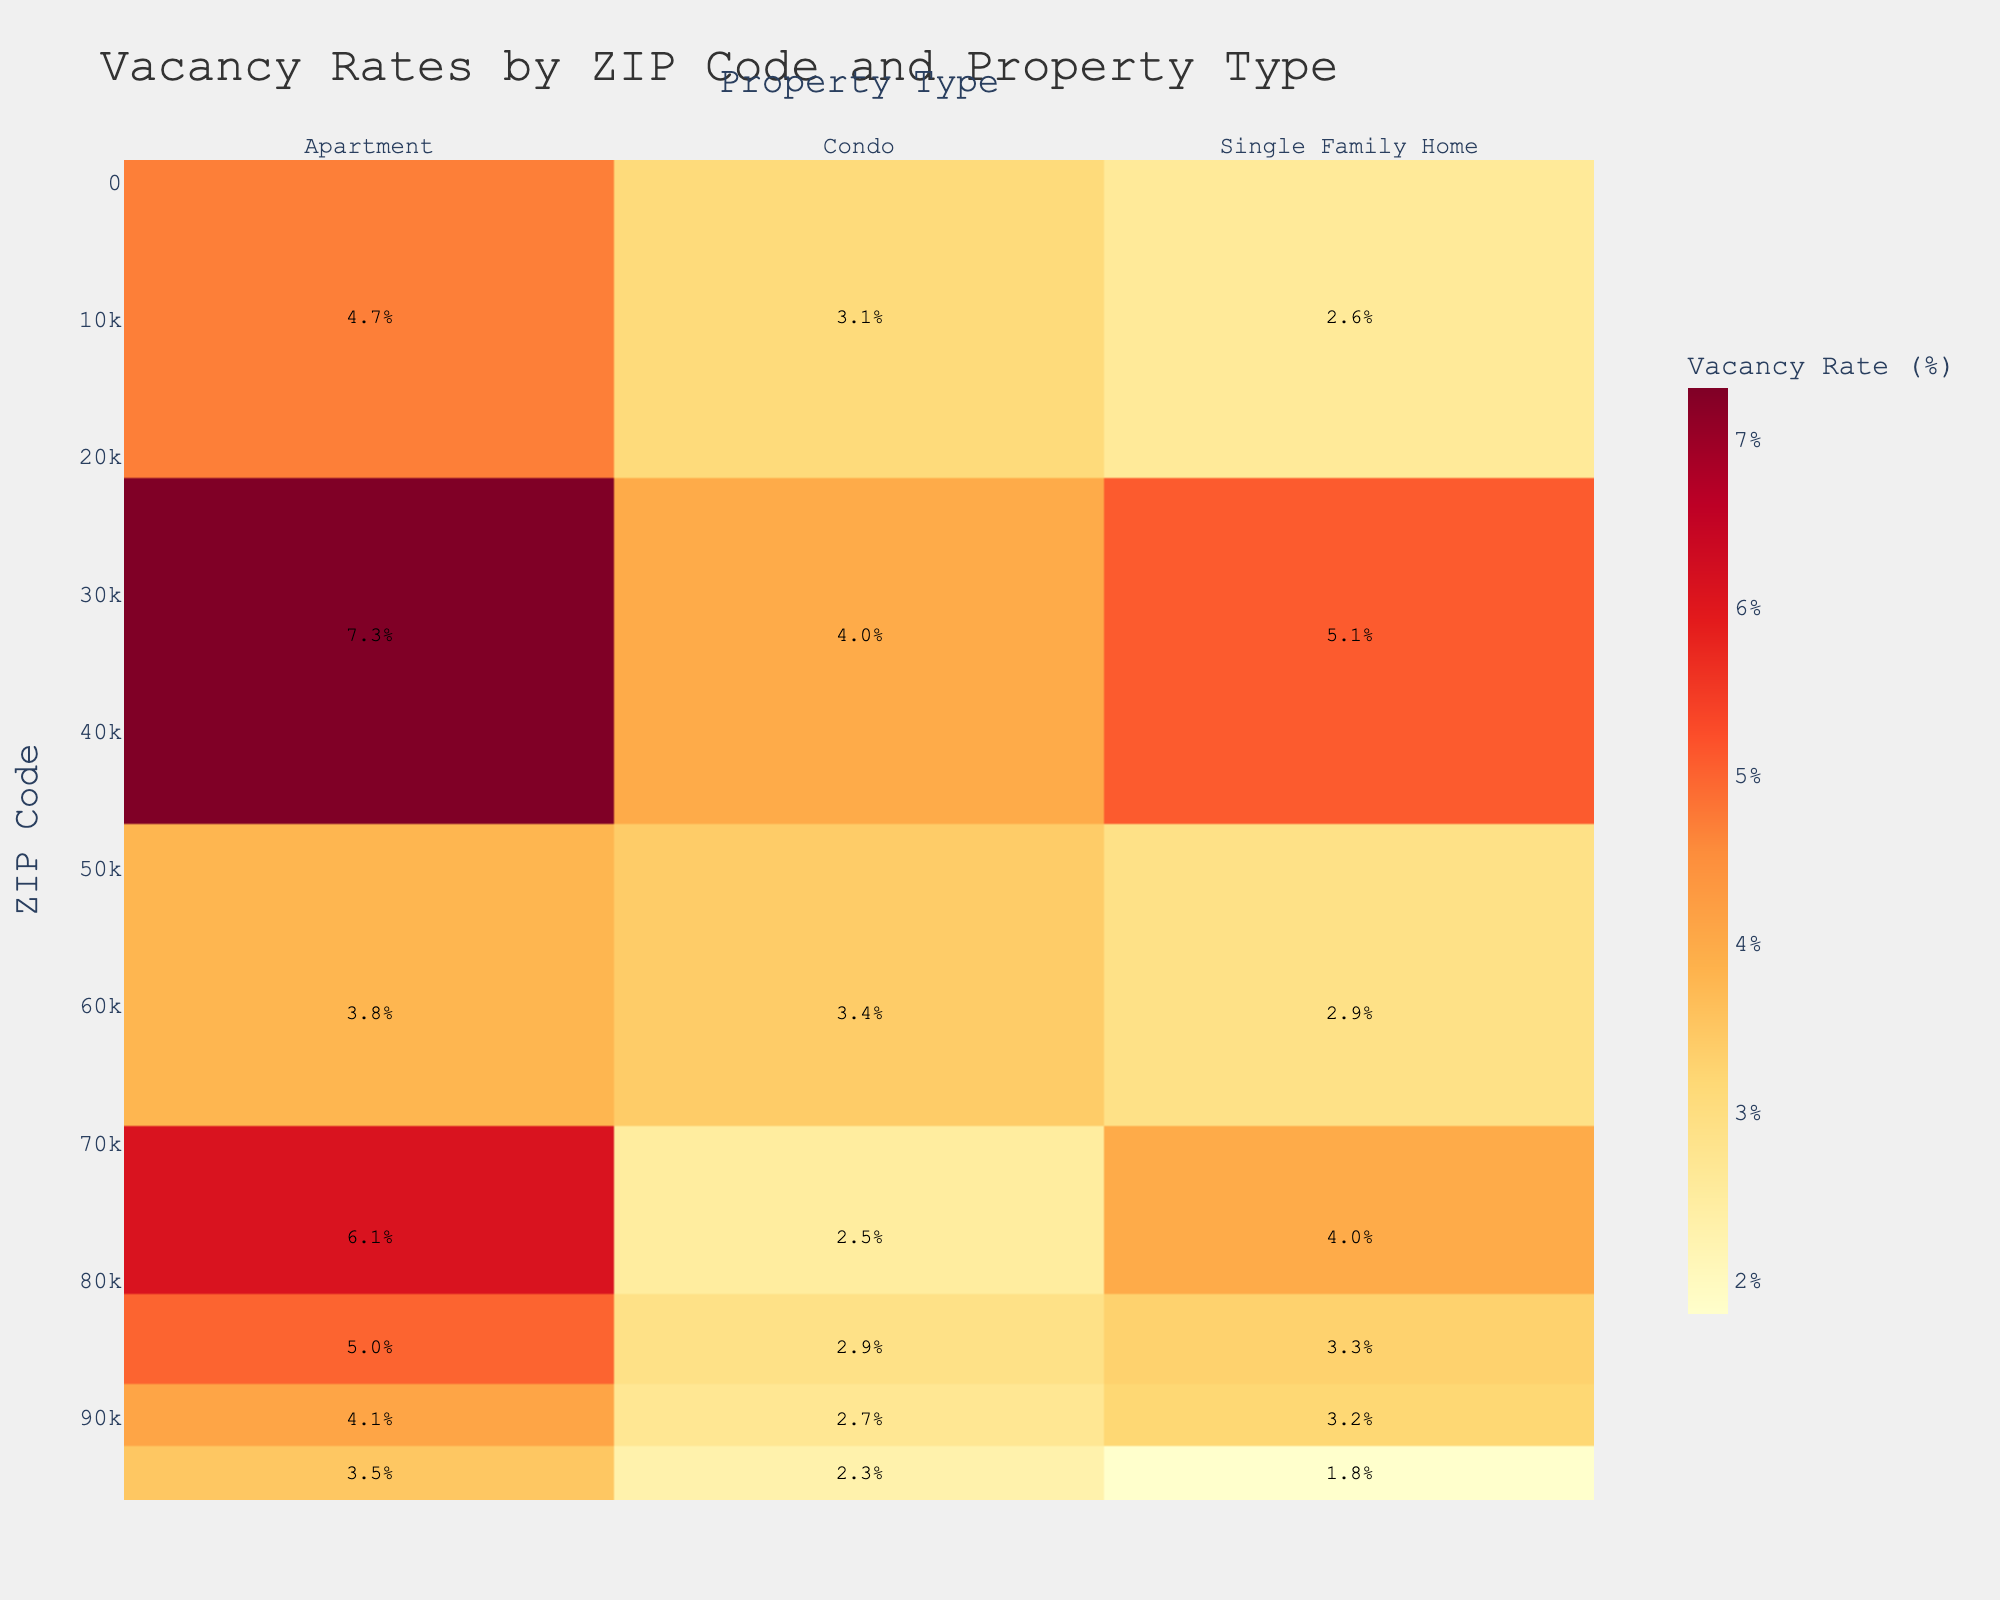What is the title of the heatmap? The title of the heatmap is displayed at the top of the figure. It helps viewers understand the context of the data being visualized.
Answer: Vacancy Rates by ZIP Code and Property Type What is the vacancy rate for Single Family Homes in ZIP Code 90210? Find the value at the intersection of the row labeled '90210' and the column labeled 'Single Family Home'.
Answer: 3.2% Which ZIP Code has the highest vacancy rate for apartments? Look at the 'Apartment' column and identify the highest value.
Answer: 33131 How does the vacancy rate for Condos in ZIP Code 77005 compare to ZIP Code 85004? Compare the values at the intersection of '77005' and 'Condo' and '85004' and 'Condo'.
Answer: 77005 has a lower vacancy rate (2.5%) compared to 85004 (2.9%) What is the range of vacancy rates for Single Family Homes across the ZIP Codes shown? Identify the minimum and maximum values in the 'Single Family Home' column. The range is the difference between these values.
Answer: Range is 5.1% - 1.8% = 3.3% Which property type generally has the highest vacancy rates across the ZIP Codes? Compare the average vacancy rates of each property type across all ZIP Codes. The property type with the highest average is the answer.
Answer: Apartment What is the difference in vacancy rates between Condos and Apartments in ZIP Code 10001? Subtract the vacancy rate for Condos (3.1%) from the vacancy rate for Apartments (4.7%) in ZIP Code 10001.
Answer: 1.6% Which ZIP Code has the lowest overall vacancy rates? Calculate the average vacancy rate across all property types for each ZIP Code and find the smallest average.
Answer: 94109 What is the color used to represent the highest vacancy rates in the heatmap? Note the color scale used in the heatmap, which is given by the yellow-orange-red scale. The highest rates are represented by the red part of the scale.
Answer: Red What can you infer about the overall vacancy rates in ZIP Code 90210 compared to ZIP Code 33131? Compare the vacancy rates of each property type in 90210 and 33131. 33131 generally has higher vacancy rates across different property types compared to 90210.
Answer: ZIP Code 33131 generally has higher vacancy rates than ZIP Code 90210 